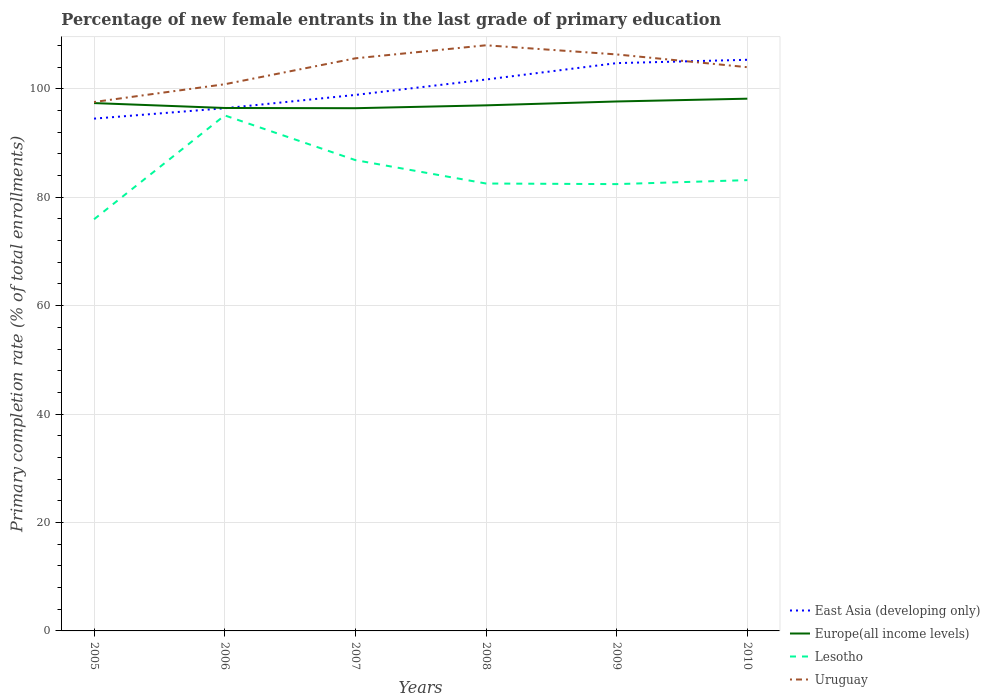How many different coloured lines are there?
Offer a terse response. 4. Does the line corresponding to Uruguay intersect with the line corresponding to East Asia (developing only)?
Make the answer very short. Yes. Across all years, what is the maximum percentage of new female entrants in Uruguay?
Offer a terse response. 97.57. What is the total percentage of new female entrants in Europe(all income levels) in the graph?
Your answer should be very brief. 0.42. What is the difference between the highest and the second highest percentage of new female entrants in Lesotho?
Provide a succinct answer. 19.16. What is the difference between the highest and the lowest percentage of new female entrants in East Asia (developing only)?
Offer a very short reply. 3. Is the percentage of new female entrants in East Asia (developing only) strictly greater than the percentage of new female entrants in Lesotho over the years?
Give a very brief answer. No. How many lines are there?
Offer a terse response. 4. Does the graph contain grids?
Keep it short and to the point. Yes. Where does the legend appear in the graph?
Provide a short and direct response. Bottom right. How many legend labels are there?
Offer a terse response. 4. What is the title of the graph?
Give a very brief answer. Percentage of new female entrants in the last grade of primary education. What is the label or title of the Y-axis?
Your answer should be very brief. Primary completion rate (% of total enrollments). What is the Primary completion rate (% of total enrollments) of East Asia (developing only) in 2005?
Your answer should be compact. 94.5. What is the Primary completion rate (% of total enrollments) in Europe(all income levels) in 2005?
Your response must be concise. 97.37. What is the Primary completion rate (% of total enrollments) of Lesotho in 2005?
Your answer should be very brief. 75.94. What is the Primary completion rate (% of total enrollments) of Uruguay in 2005?
Ensure brevity in your answer.  97.57. What is the Primary completion rate (% of total enrollments) of East Asia (developing only) in 2006?
Your answer should be compact. 96.42. What is the Primary completion rate (% of total enrollments) of Europe(all income levels) in 2006?
Keep it short and to the point. 96.47. What is the Primary completion rate (% of total enrollments) in Lesotho in 2006?
Keep it short and to the point. 95.1. What is the Primary completion rate (% of total enrollments) in Uruguay in 2006?
Make the answer very short. 100.85. What is the Primary completion rate (% of total enrollments) in East Asia (developing only) in 2007?
Provide a succinct answer. 98.88. What is the Primary completion rate (% of total enrollments) in Europe(all income levels) in 2007?
Provide a succinct answer. 96.43. What is the Primary completion rate (% of total enrollments) in Lesotho in 2007?
Ensure brevity in your answer.  86.85. What is the Primary completion rate (% of total enrollments) of Uruguay in 2007?
Your response must be concise. 105.63. What is the Primary completion rate (% of total enrollments) of East Asia (developing only) in 2008?
Your answer should be very brief. 101.72. What is the Primary completion rate (% of total enrollments) in Europe(all income levels) in 2008?
Offer a very short reply. 96.96. What is the Primary completion rate (% of total enrollments) of Lesotho in 2008?
Your answer should be compact. 82.54. What is the Primary completion rate (% of total enrollments) of Uruguay in 2008?
Provide a short and direct response. 108.04. What is the Primary completion rate (% of total enrollments) in East Asia (developing only) in 2009?
Give a very brief answer. 104.75. What is the Primary completion rate (% of total enrollments) in Europe(all income levels) in 2009?
Give a very brief answer. 97.67. What is the Primary completion rate (% of total enrollments) in Lesotho in 2009?
Ensure brevity in your answer.  82.43. What is the Primary completion rate (% of total enrollments) of Uruguay in 2009?
Give a very brief answer. 106.35. What is the Primary completion rate (% of total enrollments) in East Asia (developing only) in 2010?
Give a very brief answer. 105.36. What is the Primary completion rate (% of total enrollments) of Europe(all income levels) in 2010?
Your answer should be compact. 98.18. What is the Primary completion rate (% of total enrollments) of Lesotho in 2010?
Give a very brief answer. 83.16. What is the Primary completion rate (% of total enrollments) in Uruguay in 2010?
Provide a succinct answer. 103.99. Across all years, what is the maximum Primary completion rate (% of total enrollments) in East Asia (developing only)?
Provide a short and direct response. 105.36. Across all years, what is the maximum Primary completion rate (% of total enrollments) in Europe(all income levels)?
Provide a succinct answer. 98.18. Across all years, what is the maximum Primary completion rate (% of total enrollments) in Lesotho?
Your answer should be compact. 95.1. Across all years, what is the maximum Primary completion rate (% of total enrollments) in Uruguay?
Ensure brevity in your answer.  108.04. Across all years, what is the minimum Primary completion rate (% of total enrollments) of East Asia (developing only)?
Your answer should be very brief. 94.5. Across all years, what is the minimum Primary completion rate (% of total enrollments) of Europe(all income levels)?
Keep it short and to the point. 96.43. Across all years, what is the minimum Primary completion rate (% of total enrollments) in Lesotho?
Keep it short and to the point. 75.94. Across all years, what is the minimum Primary completion rate (% of total enrollments) in Uruguay?
Ensure brevity in your answer.  97.57. What is the total Primary completion rate (% of total enrollments) of East Asia (developing only) in the graph?
Your response must be concise. 601.63. What is the total Primary completion rate (% of total enrollments) in Europe(all income levels) in the graph?
Offer a terse response. 583.08. What is the total Primary completion rate (% of total enrollments) in Lesotho in the graph?
Make the answer very short. 506.02. What is the total Primary completion rate (% of total enrollments) in Uruguay in the graph?
Provide a succinct answer. 622.43. What is the difference between the Primary completion rate (% of total enrollments) in East Asia (developing only) in 2005 and that in 2006?
Your answer should be compact. -1.92. What is the difference between the Primary completion rate (% of total enrollments) in Europe(all income levels) in 2005 and that in 2006?
Ensure brevity in your answer.  0.9. What is the difference between the Primary completion rate (% of total enrollments) of Lesotho in 2005 and that in 2006?
Your response must be concise. -19.16. What is the difference between the Primary completion rate (% of total enrollments) of Uruguay in 2005 and that in 2006?
Keep it short and to the point. -3.28. What is the difference between the Primary completion rate (% of total enrollments) in East Asia (developing only) in 2005 and that in 2007?
Offer a very short reply. -4.37. What is the difference between the Primary completion rate (% of total enrollments) of Europe(all income levels) in 2005 and that in 2007?
Provide a succinct answer. 0.94. What is the difference between the Primary completion rate (% of total enrollments) of Lesotho in 2005 and that in 2007?
Give a very brief answer. -10.91. What is the difference between the Primary completion rate (% of total enrollments) of Uruguay in 2005 and that in 2007?
Make the answer very short. -8.06. What is the difference between the Primary completion rate (% of total enrollments) of East Asia (developing only) in 2005 and that in 2008?
Give a very brief answer. -7.22. What is the difference between the Primary completion rate (% of total enrollments) in Europe(all income levels) in 2005 and that in 2008?
Give a very brief answer. 0.42. What is the difference between the Primary completion rate (% of total enrollments) in Lesotho in 2005 and that in 2008?
Offer a very short reply. -6.6. What is the difference between the Primary completion rate (% of total enrollments) of Uruguay in 2005 and that in 2008?
Your answer should be very brief. -10.47. What is the difference between the Primary completion rate (% of total enrollments) of East Asia (developing only) in 2005 and that in 2009?
Your response must be concise. -10.24. What is the difference between the Primary completion rate (% of total enrollments) in Europe(all income levels) in 2005 and that in 2009?
Ensure brevity in your answer.  -0.3. What is the difference between the Primary completion rate (% of total enrollments) of Lesotho in 2005 and that in 2009?
Offer a very short reply. -6.48. What is the difference between the Primary completion rate (% of total enrollments) in Uruguay in 2005 and that in 2009?
Your answer should be compact. -8.78. What is the difference between the Primary completion rate (% of total enrollments) in East Asia (developing only) in 2005 and that in 2010?
Your answer should be very brief. -10.86. What is the difference between the Primary completion rate (% of total enrollments) in Europe(all income levels) in 2005 and that in 2010?
Make the answer very short. -0.81. What is the difference between the Primary completion rate (% of total enrollments) of Lesotho in 2005 and that in 2010?
Offer a very short reply. -7.22. What is the difference between the Primary completion rate (% of total enrollments) of Uruguay in 2005 and that in 2010?
Give a very brief answer. -6.42. What is the difference between the Primary completion rate (% of total enrollments) of East Asia (developing only) in 2006 and that in 2007?
Provide a succinct answer. -2.46. What is the difference between the Primary completion rate (% of total enrollments) in Europe(all income levels) in 2006 and that in 2007?
Offer a terse response. 0.04. What is the difference between the Primary completion rate (% of total enrollments) of Lesotho in 2006 and that in 2007?
Your answer should be compact. 8.25. What is the difference between the Primary completion rate (% of total enrollments) of Uruguay in 2006 and that in 2007?
Provide a short and direct response. -4.78. What is the difference between the Primary completion rate (% of total enrollments) of East Asia (developing only) in 2006 and that in 2008?
Provide a short and direct response. -5.3. What is the difference between the Primary completion rate (% of total enrollments) of Europe(all income levels) in 2006 and that in 2008?
Provide a short and direct response. -0.49. What is the difference between the Primary completion rate (% of total enrollments) of Lesotho in 2006 and that in 2008?
Offer a very short reply. 12.56. What is the difference between the Primary completion rate (% of total enrollments) of Uruguay in 2006 and that in 2008?
Offer a very short reply. -7.19. What is the difference between the Primary completion rate (% of total enrollments) of East Asia (developing only) in 2006 and that in 2009?
Your answer should be compact. -8.33. What is the difference between the Primary completion rate (% of total enrollments) of Europe(all income levels) in 2006 and that in 2009?
Offer a terse response. -1.2. What is the difference between the Primary completion rate (% of total enrollments) of Lesotho in 2006 and that in 2009?
Provide a succinct answer. 12.68. What is the difference between the Primary completion rate (% of total enrollments) in Uruguay in 2006 and that in 2009?
Offer a very short reply. -5.5. What is the difference between the Primary completion rate (% of total enrollments) of East Asia (developing only) in 2006 and that in 2010?
Provide a short and direct response. -8.94. What is the difference between the Primary completion rate (% of total enrollments) in Europe(all income levels) in 2006 and that in 2010?
Provide a succinct answer. -1.71. What is the difference between the Primary completion rate (% of total enrollments) in Lesotho in 2006 and that in 2010?
Your response must be concise. 11.94. What is the difference between the Primary completion rate (% of total enrollments) in Uruguay in 2006 and that in 2010?
Give a very brief answer. -3.15. What is the difference between the Primary completion rate (% of total enrollments) of East Asia (developing only) in 2007 and that in 2008?
Offer a very short reply. -2.85. What is the difference between the Primary completion rate (% of total enrollments) of Europe(all income levels) in 2007 and that in 2008?
Offer a very short reply. -0.53. What is the difference between the Primary completion rate (% of total enrollments) of Lesotho in 2007 and that in 2008?
Ensure brevity in your answer.  4.32. What is the difference between the Primary completion rate (% of total enrollments) of Uruguay in 2007 and that in 2008?
Ensure brevity in your answer.  -2.41. What is the difference between the Primary completion rate (% of total enrollments) of East Asia (developing only) in 2007 and that in 2009?
Provide a short and direct response. -5.87. What is the difference between the Primary completion rate (% of total enrollments) of Europe(all income levels) in 2007 and that in 2009?
Offer a terse response. -1.24. What is the difference between the Primary completion rate (% of total enrollments) of Lesotho in 2007 and that in 2009?
Give a very brief answer. 4.43. What is the difference between the Primary completion rate (% of total enrollments) of Uruguay in 2007 and that in 2009?
Keep it short and to the point. -0.72. What is the difference between the Primary completion rate (% of total enrollments) in East Asia (developing only) in 2007 and that in 2010?
Make the answer very short. -6.48. What is the difference between the Primary completion rate (% of total enrollments) in Europe(all income levels) in 2007 and that in 2010?
Provide a short and direct response. -1.75. What is the difference between the Primary completion rate (% of total enrollments) in Lesotho in 2007 and that in 2010?
Ensure brevity in your answer.  3.69. What is the difference between the Primary completion rate (% of total enrollments) of Uruguay in 2007 and that in 2010?
Your response must be concise. 1.64. What is the difference between the Primary completion rate (% of total enrollments) in East Asia (developing only) in 2008 and that in 2009?
Provide a succinct answer. -3.02. What is the difference between the Primary completion rate (% of total enrollments) in Europe(all income levels) in 2008 and that in 2009?
Provide a short and direct response. -0.72. What is the difference between the Primary completion rate (% of total enrollments) of Lesotho in 2008 and that in 2009?
Ensure brevity in your answer.  0.11. What is the difference between the Primary completion rate (% of total enrollments) in Uruguay in 2008 and that in 2009?
Ensure brevity in your answer.  1.69. What is the difference between the Primary completion rate (% of total enrollments) in East Asia (developing only) in 2008 and that in 2010?
Your answer should be very brief. -3.64. What is the difference between the Primary completion rate (% of total enrollments) in Europe(all income levels) in 2008 and that in 2010?
Keep it short and to the point. -1.23. What is the difference between the Primary completion rate (% of total enrollments) of Lesotho in 2008 and that in 2010?
Offer a very short reply. -0.62. What is the difference between the Primary completion rate (% of total enrollments) in Uruguay in 2008 and that in 2010?
Provide a short and direct response. 4.04. What is the difference between the Primary completion rate (% of total enrollments) in East Asia (developing only) in 2009 and that in 2010?
Keep it short and to the point. -0.61. What is the difference between the Primary completion rate (% of total enrollments) of Europe(all income levels) in 2009 and that in 2010?
Keep it short and to the point. -0.51. What is the difference between the Primary completion rate (% of total enrollments) in Lesotho in 2009 and that in 2010?
Give a very brief answer. -0.73. What is the difference between the Primary completion rate (% of total enrollments) in Uruguay in 2009 and that in 2010?
Keep it short and to the point. 2.35. What is the difference between the Primary completion rate (% of total enrollments) of East Asia (developing only) in 2005 and the Primary completion rate (% of total enrollments) of Europe(all income levels) in 2006?
Provide a short and direct response. -1.97. What is the difference between the Primary completion rate (% of total enrollments) of East Asia (developing only) in 2005 and the Primary completion rate (% of total enrollments) of Lesotho in 2006?
Provide a succinct answer. -0.6. What is the difference between the Primary completion rate (% of total enrollments) of East Asia (developing only) in 2005 and the Primary completion rate (% of total enrollments) of Uruguay in 2006?
Offer a terse response. -6.34. What is the difference between the Primary completion rate (% of total enrollments) of Europe(all income levels) in 2005 and the Primary completion rate (% of total enrollments) of Lesotho in 2006?
Your answer should be very brief. 2.27. What is the difference between the Primary completion rate (% of total enrollments) of Europe(all income levels) in 2005 and the Primary completion rate (% of total enrollments) of Uruguay in 2006?
Keep it short and to the point. -3.48. What is the difference between the Primary completion rate (% of total enrollments) of Lesotho in 2005 and the Primary completion rate (% of total enrollments) of Uruguay in 2006?
Offer a terse response. -24.91. What is the difference between the Primary completion rate (% of total enrollments) in East Asia (developing only) in 2005 and the Primary completion rate (% of total enrollments) in Europe(all income levels) in 2007?
Keep it short and to the point. -1.93. What is the difference between the Primary completion rate (% of total enrollments) in East Asia (developing only) in 2005 and the Primary completion rate (% of total enrollments) in Lesotho in 2007?
Ensure brevity in your answer.  7.65. What is the difference between the Primary completion rate (% of total enrollments) in East Asia (developing only) in 2005 and the Primary completion rate (% of total enrollments) in Uruguay in 2007?
Keep it short and to the point. -11.13. What is the difference between the Primary completion rate (% of total enrollments) in Europe(all income levels) in 2005 and the Primary completion rate (% of total enrollments) in Lesotho in 2007?
Your answer should be very brief. 10.52. What is the difference between the Primary completion rate (% of total enrollments) in Europe(all income levels) in 2005 and the Primary completion rate (% of total enrollments) in Uruguay in 2007?
Your answer should be very brief. -8.26. What is the difference between the Primary completion rate (% of total enrollments) in Lesotho in 2005 and the Primary completion rate (% of total enrollments) in Uruguay in 2007?
Offer a very short reply. -29.69. What is the difference between the Primary completion rate (% of total enrollments) of East Asia (developing only) in 2005 and the Primary completion rate (% of total enrollments) of Europe(all income levels) in 2008?
Your answer should be very brief. -2.45. What is the difference between the Primary completion rate (% of total enrollments) in East Asia (developing only) in 2005 and the Primary completion rate (% of total enrollments) in Lesotho in 2008?
Ensure brevity in your answer.  11.97. What is the difference between the Primary completion rate (% of total enrollments) in East Asia (developing only) in 2005 and the Primary completion rate (% of total enrollments) in Uruguay in 2008?
Your answer should be very brief. -13.53. What is the difference between the Primary completion rate (% of total enrollments) of Europe(all income levels) in 2005 and the Primary completion rate (% of total enrollments) of Lesotho in 2008?
Keep it short and to the point. 14.84. What is the difference between the Primary completion rate (% of total enrollments) in Europe(all income levels) in 2005 and the Primary completion rate (% of total enrollments) in Uruguay in 2008?
Offer a terse response. -10.66. What is the difference between the Primary completion rate (% of total enrollments) in Lesotho in 2005 and the Primary completion rate (% of total enrollments) in Uruguay in 2008?
Your answer should be compact. -32.1. What is the difference between the Primary completion rate (% of total enrollments) in East Asia (developing only) in 2005 and the Primary completion rate (% of total enrollments) in Europe(all income levels) in 2009?
Your response must be concise. -3.17. What is the difference between the Primary completion rate (% of total enrollments) in East Asia (developing only) in 2005 and the Primary completion rate (% of total enrollments) in Lesotho in 2009?
Your answer should be very brief. 12.08. What is the difference between the Primary completion rate (% of total enrollments) in East Asia (developing only) in 2005 and the Primary completion rate (% of total enrollments) in Uruguay in 2009?
Give a very brief answer. -11.84. What is the difference between the Primary completion rate (% of total enrollments) of Europe(all income levels) in 2005 and the Primary completion rate (% of total enrollments) of Lesotho in 2009?
Offer a very short reply. 14.95. What is the difference between the Primary completion rate (% of total enrollments) of Europe(all income levels) in 2005 and the Primary completion rate (% of total enrollments) of Uruguay in 2009?
Provide a short and direct response. -8.97. What is the difference between the Primary completion rate (% of total enrollments) in Lesotho in 2005 and the Primary completion rate (% of total enrollments) in Uruguay in 2009?
Keep it short and to the point. -30.41. What is the difference between the Primary completion rate (% of total enrollments) in East Asia (developing only) in 2005 and the Primary completion rate (% of total enrollments) in Europe(all income levels) in 2010?
Give a very brief answer. -3.68. What is the difference between the Primary completion rate (% of total enrollments) in East Asia (developing only) in 2005 and the Primary completion rate (% of total enrollments) in Lesotho in 2010?
Give a very brief answer. 11.34. What is the difference between the Primary completion rate (% of total enrollments) in East Asia (developing only) in 2005 and the Primary completion rate (% of total enrollments) in Uruguay in 2010?
Make the answer very short. -9.49. What is the difference between the Primary completion rate (% of total enrollments) of Europe(all income levels) in 2005 and the Primary completion rate (% of total enrollments) of Lesotho in 2010?
Give a very brief answer. 14.21. What is the difference between the Primary completion rate (% of total enrollments) in Europe(all income levels) in 2005 and the Primary completion rate (% of total enrollments) in Uruguay in 2010?
Offer a very short reply. -6.62. What is the difference between the Primary completion rate (% of total enrollments) of Lesotho in 2005 and the Primary completion rate (% of total enrollments) of Uruguay in 2010?
Ensure brevity in your answer.  -28.05. What is the difference between the Primary completion rate (% of total enrollments) in East Asia (developing only) in 2006 and the Primary completion rate (% of total enrollments) in Europe(all income levels) in 2007?
Provide a short and direct response. -0.01. What is the difference between the Primary completion rate (% of total enrollments) in East Asia (developing only) in 2006 and the Primary completion rate (% of total enrollments) in Lesotho in 2007?
Your answer should be compact. 9.57. What is the difference between the Primary completion rate (% of total enrollments) in East Asia (developing only) in 2006 and the Primary completion rate (% of total enrollments) in Uruguay in 2007?
Offer a very short reply. -9.21. What is the difference between the Primary completion rate (% of total enrollments) in Europe(all income levels) in 2006 and the Primary completion rate (% of total enrollments) in Lesotho in 2007?
Your answer should be compact. 9.62. What is the difference between the Primary completion rate (% of total enrollments) in Europe(all income levels) in 2006 and the Primary completion rate (% of total enrollments) in Uruguay in 2007?
Your answer should be very brief. -9.16. What is the difference between the Primary completion rate (% of total enrollments) in Lesotho in 2006 and the Primary completion rate (% of total enrollments) in Uruguay in 2007?
Make the answer very short. -10.53. What is the difference between the Primary completion rate (% of total enrollments) in East Asia (developing only) in 2006 and the Primary completion rate (% of total enrollments) in Europe(all income levels) in 2008?
Make the answer very short. -0.54. What is the difference between the Primary completion rate (% of total enrollments) in East Asia (developing only) in 2006 and the Primary completion rate (% of total enrollments) in Lesotho in 2008?
Provide a short and direct response. 13.88. What is the difference between the Primary completion rate (% of total enrollments) of East Asia (developing only) in 2006 and the Primary completion rate (% of total enrollments) of Uruguay in 2008?
Make the answer very short. -11.62. What is the difference between the Primary completion rate (% of total enrollments) of Europe(all income levels) in 2006 and the Primary completion rate (% of total enrollments) of Lesotho in 2008?
Your response must be concise. 13.93. What is the difference between the Primary completion rate (% of total enrollments) in Europe(all income levels) in 2006 and the Primary completion rate (% of total enrollments) in Uruguay in 2008?
Ensure brevity in your answer.  -11.57. What is the difference between the Primary completion rate (% of total enrollments) of Lesotho in 2006 and the Primary completion rate (% of total enrollments) of Uruguay in 2008?
Make the answer very short. -12.94. What is the difference between the Primary completion rate (% of total enrollments) in East Asia (developing only) in 2006 and the Primary completion rate (% of total enrollments) in Europe(all income levels) in 2009?
Offer a very short reply. -1.25. What is the difference between the Primary completion rate (% of total enrollments) in East Asia (developing only) in 2006 and the Primary completion rate (% of total enrollments) in Lesotho in 2009?
Offer a very short reply. 14. What is the difference between the Primary completion rate (% of total enrollments) of East Asia (developing only) in 2006 and the Primary completion rate (% of total enrollments) of Uruguay in 2009?
Your response must be concise. -9.93. What is the difference between the Primary completion rate (% of total enrollments) in Europe(all income levels) in 2006 and the Primary completion rate (% of total enrollments) in Lesotho in 2009?
Give a very brief answer. 14.04. What is the difference between the Primary completion rate (% of total enrollments) of Europe(all income levels) in 2006 and the Primary completion rate (% of total enrollments) of Uruguay in 2009?
Your answer should be very brief. -9.88. What is the difference between the Primary completion rate (% of total enrollments) in Lesotho in 2006 and the Primary completion rate (% of total enrollments) in Uruguay in 2009?
Provide a short and direct response. -11.25. What is the difference between the Primary completion rate (% of total enrollments) of East Asia (developing only) in 2006 and the Primary completion rate (% of total enrollments) of Europe(all income levels) in 2010?
Your answer should be very brief. -1.76. What is the difference between the Primary completion rate (% of total enrollments) in East Asia (developing only) in 2006 and the Primary completion rate (% of total enrollments) in Lesotho in 2010?
Keep it short and to the point. 13.26. What is the difference between the Primary completion rate (% of total enrollments) in East Asia (developing only) in 2006 and the Primary completion rate (% of total enrollments) in Uruguay in 2010?
Make the answer very short. -7.57. What is the difference between the Primary completion rate (% of total enrollments) of Europe(all income levels) in 2006 and the Primary completion rate (% of total enrollments) of Lesotho in 2010?
Your answer should be compact. 13.31. What is the difference between the Primary completion rate (% of total enrollments) in Europe(all income levels) in 2006 and the Primary completion rate (% of total enrollments) in Uruguay in 2010?
Offer a terse response. -7.52. What is the difference between the Primary completion rate (% of total enrollments) of Lesotho in 2006 and the Primary completion rate (% of total enrollments) of Uruguay in 2010?
Provide a short and direct response. -8.89. What is the difference between the Primary completion rate (% of total enrollments) in East Asia (developing only) in 2007 and the Primary completion rate (% of total enrollments) in Europe(all income levels) in 2008?
Your answer should be very brief. 1.92. What is the difference between the Primary completion rate (% of total enrollments) of East Asia (developing only) in 2007 and the Primary completion rate (% of total enrollments) of Lesotho in 2008?
Your response must be concise. 16.34. What is the difference between the Primary completion rate (% of total enrollments) in East Asia (developing only) in 2007 and the Primary completion rate (% of total enrollments) in Uruguay in 2008?
Give a very brief answer. -9.16. What is the difference between the Primary completion rate (% of total enrollments) of Europe(all income levels) in 2007 and the Primary completion rate (% of total enrollments) of Lesotho in 2008?
Make the answer very short. 13.89. What is the difference between the Primary completion rate (% of total enrollments) of Europe(all income levels) in 2007 and the Primary completion rate (% of total enrollments) of Uruguay in 2008?
Your response must be concise. -11.61. What is the difference between the Primary completion rate (% of total enrollments) of Lesotho in 2007 and the Primary completion rate (% of total enrollments) of Uruguay in 2008?
Make the answer very short. -21.18. What is the difference between the Primary completion rate (% of total enrollments) in East Asia (developing only) in 2007 and the Primary completion rate (% of total enrollments) in Europe(all income levels) in 2009?
Keep it short and to the point. 1.21. What is the difference between the Primary completion rate (% of total enrollments) in East Asia (developing only) in 2007 and the Primary completion rate (% of total enrollments) in Lesotho in 2009?
Offer a very short reply. 16.45. What is the difference between the Primary completion rate (% of total enrollments) in East Asia (developing only) in 2007 and the Primary completion rate (% of total enrollments) in Uruguay in 2009?
Make the answer very short. -7.47. What is the difference between the Primary completion rate (% of total enrollments) of Europe(all income levels) in 2007 and the Primary completion rate (% of total enrollments) of Lesotho in 2009?
Give a very brief answer. 14. What is the difference between the Primary completion rate (% of total enrollments) of Europe(all income levels) in 2007 and the Primary completion rate (% of total enrollments) of Uruguay in 2009?
Offer a very short reply. -9.92. What is the difference between the Primary completion rate (% of total enrollments) of Lesotho in 2007 and the Primary completion rate (% of total enrollments) of Uruguay in 2009?
Provide a short and direct response. -19.49. What is the difference between the Primary completion rate (% of total enrollments) in East Asia (developing only) in 2007 and the Primary completion rate (% of total enrollments) in Europe(all income levels) in 2010?
Give a very brief answer. 0.69. What is the difference between the Primary completion rate (% of total enrollments) in East Asia (developing only) in 2007 and the Primary completion rate (% of total enrollments) in Lesotho in 2010?
Make the answer very short. 15.72. What is the difference between the Primary completion rate (% of total enrollments) of East Asia (developing only) in 2007 and the Primary completion rate (% of total enrollments) of Uruguay in 2010?
Offer a very short reply. -5.12. What is the difference between the Primary completion rate (% of total enrollments) of Europe(all income levels) in 2007 and the Primary completion rate (% of total enrollments) of Lesotho in 2010?
Your response must be concise. 13.27. What is the difference between the Primary completion rate (% of total enrollments) in Europe(all income levels) in 2007 and the Primary completion rate (% of total enrollments) in Uruguay in 2010?
Provide a short and direct response. -7.56. What is the difference between the Primary completion rate (% of total enrollments) in Lesotho in 2007 and the Primary completion rate (% of total enrollments) in Uruguay in 2010?
Your answer should be very brief. -17.14. What is the difference between the Primary completion rate (% of total enrollments) of East Asia (developing only) in 2008 and the Primary completion rate (% of total enrollments) of Europe(all income levels) in 2009?
Ensure brevity in your answer.  4.05. What is the difference between the Primary completion rate (% of total enrollments) in East Asia (developing only) in 2008 and the Primary completion rate (% of total enrollments) in Lesotho in 2009?
Your answer should be very brief. 19.3. What is the difference between the Primary completion rate (% of total enrollments) in East Asia (developing only) in 2008 and the Primary completion rate (% of total enrollments) in Uruguay in 2009?
Ensure brevity in your answer.  -4.63. What is the difference between the Primary completion rate (% of total enrollments) in Europe(all income levels) in 2008 and the Primary completion rate (% of total enrollments) in Lesotho in 2009?
Provide a succinct answer. 14.53. What is the difference between the Primary completion rate (% of total enrollments) of Europe(all income levels) in 2008 and the Primary completion rate (% of total enrollments) of Uruguay in 2009?
Offer a terse response. -9.39. What is the difference between the Primary completion rate (% of total enrollments) in Lesotho in 2008 and the Primary completion rate (% of total enrollments) in Uruguay in 2009?
Offer a very short reply. -23.81. What is the difference between the Primary completion rate (% of total enrollments) of East Asia (developing only) in 2008 and the Primary completion rate (% of total enrollments) of Europe(all income levels) in 2010?
Provide a succinct answer. 3.54. What is the difference between the Primary completion rate (% of total enrollments) of East Asia (developing only) in 2008 and the Primary completion rate (% of total enrollments) of Lesotho in 2010?
Ensure brevity in your answer.  18.56. What is the difference between the Primary completion rate (% of total enrollments) of East Asia (developing only) in 2008 and the Primary completion rate (% of total enrollments) of Uruguay in 2010?
Make the answer very short. -2.27. What is the difference between the Primary completion rate (% of total enrollments) in Europe(all income levels) in 2008 and the Primary completion rate (% of total enrollments) in Lesotho in 2010?
Ensure brevity in your answer.  13.8. What is the difference between the Primary completion rate (% of total enrollments) in Europe(all income levels) in 2008 and the Primary completion rate (% of total enrollments) in Uruguay in 2010?
Your answer should be very brief. -7.04. What is the difference between the Primary completion rate (% of total enrollments) in Lesotho in 2008 and the Primary completion rate (% of total enrollments) in Uruguay in 2010?
Offer a very short reply. -21.46. What is the difference between the Primary completion rate (% of total enrollments) of East Asia (developing only) in 2009 and the Primary completion rate (% of total enrollments) of Europe(all income levels) in 2010?
Provide a succinct answer. 6.56. What is the difference between the Primary completion rate (% of total enrollments) in East Asia (developing only) in 2009 and the Primary completion rate (% of total enrollments) in Lesotho in 2010?
Make the answer very short. 21.59. What is the difference between the Primary completion rate (% of total enrollments) of East Asia (developing only) in 2009 and the Primary completion rate (% of total enrollments) of Uruguay in 2010?
Keep it short and to the point. 0.75. What is the difference between the Primary completion rate (% of total enrollments) in Europe(all income levels) in 2009 and the Primary completion rate (% of total enrollments) in Lesotho in 2010?
Offer a very short reply. 14.51. What is the difference between the Primary completion rate (% of total enrollments) in Europe(all income levels) in 2009 and the Primary completion rate (% of total enrollments) in Uruguay in 2010?
Offer a very short reply. -6.32. What is the difference between the Primary completion rate (% of total enrollments) of Lesotho in 2009 and the Primary completion rate (% of total enrollments) of Uruguay in 2010?
Keep it short and to the point. -21.57. What is the average Primary completion rate (% of total enrollments) in East Asia (developing only) per year?
Offer a very short reply. 100.27. What is the average Primary completion rate (% of total enrollments) of Europe(all income levels) per year?
Give a very brief answer. 97.18. What is the average Primary completion rate (% of total enrollments) in Lesotho per year?
Offer a very short reply. 84.34. What is the average Primary completion rate (% of total enrollments) in Uruguay per year?
Offer a terse response. 103.74. In the year 2005, what is the difference between the Primary completion rate (% of total enrollments) of East Asia (developing only) and Primary completion rate (% of total enrollments) of Europe(all income levels)?
Provide a short and direct response. -2.87. In the year 2005, what is the difference between the Primary completion rate (% of total enrollments) in East Asia (developing only) and Primary completion rate (% of total enrollments) in Lesotho?
Offer a very short reply. 18.56. In the year 2005, what is the difference between the Primary completion rate (% of total enrollments) of East Asia (developing only) and Primary completion rate (% of total enrollments) of Uruguay?
Provide a succinct answer. -3.07. In the year 2005, what is the difference between the Primary completion rate (% of total enrollments) of Europe(all income levels) and Primary completion rate (% of total enrollments) of Lesotho?
Provide a succinct answer. 21.43. In the year 2005, what is the difference between the Primary completion rate (% of total enrollments) of Europe(all income levels) and Primary completion rate (% of total enrollments) of Uruguay?
Ensure brevity in your answer.  -0.2. In the year 2005, what is the difference between the Primary completion rate (% of total enrollments) of Lesotho and Primary completion rate (% of total enrollments) of Uruguay?
Ensure brevity in your answer.  -21.63. In the year 2006, what is the difference between the Primary completion rate (% of total enrollments) of East Asia (developing only) and Primary completion rate (% of total enrollments) of Europe(all income levels)?
Your answer should be compact. -0.05. In the year 2006, what is the difference between the Primary completion rate (% of total enrollments) in East Asia (developing only) and Primary completion rate (% of total enrollments) in Lesotho?
Make the answer very short. 1.32. In the year 2006, what is the difference between the Primary completion rate (% of total enrollments) in East Asia (developing only) and Primary completion rate (% of total enrollments) in Uruguay?
Ensure brevity in your answer.  -4.43. In the year 2006, what is the difference between the Primary completion rate (% of total enrollments) in Europe(all income levels) and Primary completion rate (% of total enrollments) in Lesotho?
Give a very brief answer. 1.37. In the year 2006, what is the difference between the Primary completion rate (% of total enrollments) of Europe(all income levels) and Primary completion rate (% of total enrollments) of Uruguay?
Keep it short and to the point. -4.38. In the year 2006, what is the difference between the Primary completion rate (% of total enrollments) of Lesotho and Primary completion rate (% of total enrollments) of Uruguay?
Keep it short and to the point. -5.75. In the year 2007, what is the difference between the Primary completion rate (% of total enrollments) in East Asia (developing only) and Primary completion rate (% of total enrollments) in Europe(all income levels)?
Offer a terse response. 2.45. In the year 2007, what is the difference between the Primary completion rate (% of total enrollments) of East Asia (developing only) and Primary completion rate (% of total enrollments) of Lesotho?
Ensure brevity in your answer.  12.02. In the year 2007, what is the difference between the Primary completion rate (% of total enrollments) of East Asia (developing only) and Primary completion rate (% of total enrollments) of Uruguay?
Provide a short and direct response. -6.75. In the year 2007, what is the difference between the Primary completion rate (% of total enrollments) of Europe(all income levels) and Primary completion rate (% of total enrollments) of Lesotho?
Offer a terse response. 9.58. In the year 2007, what is the difference between the Primary completion rate (% of total enrollments) in Europe(all income levels) and Primary completion rate (% of total enrollments) in Uruguay?
Your answer should be very brief. -9.2. In the year 2007, what is the difference between the Primary completion rate (% of total enrollments) of Lesotho and Primary completion rate (% of total enrollments) of Uruguay?
Make the answer very short. -18.78. In the year 2008, what is the difference between the Primary completion rate (% of total enrollments) in East Asia (developing only) and Primary completion rate (% of total enrollments) in Europe(all income levels)?
Give a very brief answer. 4.77. In the year 2008, what is the difference between the Primary completion rate (% of total enrollments) in East Asia (developing only) and Primary completion rate (% of total enrollments) in Lesotho?
Your response must be concise. 19.19. In the year 2008, what is the difference between the Primary completion rate (% of total enrollments) of East Asia (developing only) and Primary completion rate (% of total enrollments) of Uruguay?
Offer a terse response. -6.32. In the year 2008, what is the difference between the Primary completion rate (% of total enrollments) in Europe(all income levels) and Primary completion rate (% of total enrollments) in Lesotho?
Offer a terse response. 14.42. In the year 2008, what is the difference between the Primary completion rate (% of total enrollments) of Europe(all income levels) and Primary completion rate (% of total enrollments) of Uruguay?
Your response must be concise. -11.08. In the year 2008, what is the difference between the Primary completion rate (% of total enrollments) of Lesotho and Primary completion rate (% of total enrollments) of Uruguay?
Your answer should be very brief. -25.5. In the year 2009, what is the difference between the Primary completion rate (% of total enrollments) of East Asia (developing only) and Primary completion rate (% of total enrollments) of Europe(all income levels)?
Offer a terse response. 7.08. In the year 2009, what is the difference between the Primary completion rate (% of total enrollments) of East Asia (developing only) and Primary completion rate (% of total enrollments) of Lesotho?
Offer a terse response. 22.32. In the year 2009, what is the difference between the Primary completion rate (% of total enrollments) of East Asia (developing only) and Primary completion rate (% of total enrollments) of Uruguay?
Ensure brevity in your answer.  -1.6. In the year 2009, what is the difference between the Primary completion rate (% of total enrollments) in Europe(all income levels) and Primary completion rate (% of total enrollments) in Lesotho?
Offer a terse response. 15.25. In the year 2009, what is the difference between the Primary completion rate (% of total enrollments) in Europe(all income levels) and Primary completion rate (% of total enrollments) in Uruguay?
Your answer should be very brief. -8.68. In the year 2009, what is the difference between the Primary completion rate (% of total enrollments) in Lesotho and Primary completion rate (% of total enrollments) in Uruguay?
Offer a very short reply. -23.92. In the year 2010, what is the difference between the Primary completion rate (% of total enrollments) in East Asia (developing only) and Primary completion rate (% of total enrollments) in Europe(all income levels)?
Offer a very short reply. 7.18. In the year 2010, what is the difference between the Primary completion rate (% of total enrollments) of East Asia (developing only) and Primary completion rate (% of total enrollments) of Lesotho?
Your response must be concise. 22.2. In the year 2010, what is the difference between the Primary completion rate (% of total enrollments) in East Asia (developing only) and Primary completion rate (% of total enrollments) in Uruguay?
Your answer should be compact. 1.37. In the year 2010, what is the difference between the Primary completion rate (% of total enrollments) in Europe(all income levels) and Primary completion rate (% of total enrollments) in Lesotho?
Keep it short and to the point. 15.02. In the year 2010, what is the difference between the Primary completion rate (% of total enrollments) in Europe(all income levels) and Primary completion rate (% of total enrollments) in Uruguay?
Your response must be concise. -5.81. In the year 2010, what is the difference between the Primary completion rate (% of total enrollments) in Lesotho and Primary completion rate (% of total enrollments) in Uruguay?
Your response must be concise. -20.83. What is the ratio of the Primary completion rate (% of total enrollments) in East Asia (developing only) in 2005 to that in 2006?
Keep it short and to the point. 0.98. What is the ratio of the Primary completion rate (% of total enrollments) of Europe(all income levels) in 2005 to that in 2006?
Make the answer very short. 1.01. What is the ratio of the Primary completion rate (% of total enrollments) in Lesotho in 2005 to that in 2006?
Make the answer very short. 0.8. What is the ratio of the Primary completion rate (% of total enrollments) of Uruguay in 2005 to that in 2006?
Your response must be concise. 0.97. What is the ratio of the Primary completion rate (% of total enrollments) of East Asia (developing only) in 2005 to that in 2007?
Ensure brevity in your answer.  0.96. What is the ratio of the Primary completion rate (% of total enrollments) of Europe(all income levels) in 2005 to that in 2007?
Keep it short and to the point. 1.01. What is the ratio of the Primary completion rate (% of total enrollments) of Lesotho in 2005 to that in 2007?
Your answer should be very brief. 0.87. What is the ratio of the Primary completion rate (% of total enrollments) of Uruguay in 2005 to that in 2007?
Make the answer very short. 0.92. What is the ratio of the Primary completion rate (% of total enrollments) of East Asia (developing only) in 2005 to that in 2008?
Offer a terse response. 0.93. What is the ratio of the Primary completion rate (% of total enrollments) of Europe(all income levels) in 2005 to that in 2008?
Give a very brief answer. 1. What is the ratio of the Primary completion rate (% of total enrollments) in Lesotho in 2005 to that in 2008?
Make the answer very short. 0.92. What is the ratio of the Primary completion rate (% of total enrollments) in Uruguay in 2005 to that in 2008?
Your response must be concise. 0.9. What is the ratio of the Primary completion rate (% of total enrollments) of East Asia (developing only) in 2005 to that in 2009?
Ensure brevity in your answer.  0.9. What is the ratio of the Primary completion rate (% of total enrollments) in Europe(all income levels) in 2005 to that in 2009?
Your answer should be compact. 1. What is the ratio of the Primary completion rate (% of total enrollments) of Lesotho in 2005 to that in 2009?
Your answer should be very brief. 0.92. What is the ratio of the Primary completion rate (% of total enrollments) of Uruguay in 2005 to that in 2009?
Your answer should be compact. 0.92. What is the ratio of the Primary completion rate (% of total enrollments) in East Asia (developing only) in 2005 to that in 2010?
Your response must be concise. 0.9. What is the ratio of the Primary completion rate (% of total enrollments) of Europe(all income levels) in 2005 to that in 2010?
Provide a succinct answer. 0.99. What is the ratio of the Primary completion rate (% of total enrollments) in Lesotho in 2005 to that in 2010?
Your answer should be compact. 0.91. What is the ratio of the Primary completion rate (% of total enrollments) in Uruguay in 2005 to that in 2010?
Provide a succinct answer. 0.94. What is the ratio of the Primary completion rate (% of total enrollments) of East Asia (developing only) in 2006 to that in 2007?
Give a very brief answer. 0.98. What is the ratio of the Primary completion rate (% of total enrollments) in Europe(all income levels) in 2006 to that in 2007?
Your response must be concise. 1. What is the ratio of the Primary completion rate (% of total enrollments) of Lesotho in 2006 to that in 2007?
Offer a terse response. 1.09. What is the ratio of the Primary completion rate (% of total enrollments) of Uruguay in 2006 to that in 2007?
Provide a short and direct response. 0.95. What is the ratio of the Primary completion rate (% of total enrollments) in East Asia (developing only) in 2006 to that in 2008?
Offer a very short reply. 0.95. What is the ratio of the Primary completion rate (% of total enrollments) in Europe(all income levels) in 2006 to that in 2008?
Give a very brief answer. 0.99. What is the ratio of the Primary completion rate (% of total enrollments) in Lesotho in 2006 to that in 2008?
Give a very brief answer. 1.15. What is the ratio of the Primary completion rate (% of total enrollments) in Uruguay in 2006 to that in 2008?
Provide a short and direct response. 0.93. What is the ratio of the Primary completion rate (% of total enrollments) of East Asia (developing only) in 2006 to that in 2009?
Provide a succinct answer. 0.92. What is the ratio of the Primary completion rate (% of total enrollments) of Europe(all income levels) in 2006 to that in 2009?
Offer a very short reply. 0.99. What is the ratio of the Primary completion rate (% of total enrollments) of Lesotho in 2006 to that in 2009?
Keep it short and to the point. 1.15. What is the ratio of the Primary completion rate (% of total enrollments) in Uruguay in 2006 to that in 2009?
Offer a very short reply. 0.95. What is the ratio of the Primary completion rate (% of total enrollments) of East Asia (developing only) in 2006 to that in 2010?
Offer a very short reply. 0.92. What is the ratio of the Primary completion rate (% of total enrollments) in Europe(all income levels) in 2006 to that in 2010?
Offer a terse response. 0.98. What is the ratio of the Primary completion rate (% of total enrollments) of Lesotho in 2006 to that in 2010?
Provide a short and direct response. 1.14. What is the ratio of the Primary completion rate (% of total enrollments) in Uruguay in 2006 to that in 2010?
Make the answer very short. 0.97. What is the ratio of the Primary completion rate (% of total enrollments) of Lesotho in 2007 to that in 2008?
Ensure brevity in your answer.  1.05. What is the ratio of the Primary completion rate (% of total enrollments) of Uruguay in 2007 to that in 2008?
Keep it short and to the point. 0.98. What is the ratio of the Primary completion rate (% of total enrollments) in East Asia (developing only) in 2007 to that in 2009?
Offer a terse response. 0.94. What is the ratio of the Primary completion rate (% of total enrollments) in Europe(all income levels) in 2007 to that in 2009?
Provide a short and direct response. 0.99. What is the ratio of the Primary completion rate (% of total enrollments) of Lesotho in 2007 to that in 2009?
Provide a short and direct response. 1.05. What is the ratio of the Primary completion rate (% of total enrollments) of East Asia (developing only) in 2007 to that in 2010?
Make the answer very short. 0.94. What is the ratio of the Primary completion rate (% of total enrollments) of Europe(all income levels) in 2007 to that in 2010?
Provide a short and direct response. 0.98. What is the ratio of the Primary completion rate (% of total enrollments) of Lesotho in 2007 to that in 2010?
Provide a succinct answer. 1.04. What is the ratio of the Primary completion rate (% of total enrollments) of Uruguay in 2007 to that in 2010?
Your response must be concise. 1.02. What is the ratio of the Primary completion rate (% of total enrollments) in East Asia (developing only) in 2008 to that in 2009?
Give a very brief answer. 0.97. What is the ratio of the Primary completion rate (% of total enrollments) in Europe(all income levels) in 2008 to that in 2009?
Keep it short and to the point. 0.99. What is the ratio of the Primary completion rate (% of total enrollments) of Uruguay in 2008 to that in 2009?
Make the answer very short. 1.02. What is the ratio of the Primary completion rate (% of total enrollments) of East Asia (developing only) in 2008 to that in 2010?
Keep it short and to the point. 0.97. What is the ratio of the Primary completion rate (% of total enrollments) in Europe(all income levels) in 2008 to that in 2010?
Provide a succinct answer. 0.99. What is the ratio of the Primary completion rate (% of total enrollments) in Lesotho in 2008 to that in 2010?
Keep it short and to the point. 0.99. What is the ratio of the Primary completion rate (% of total enrollments) in Uruguay in 2008 to that in 2010?
Give a very brief answer. 1.04. What is the ratio of the Primary completion rate (% of total enrollments) of Uruguay in 2009 to that in 2010?
Your response must be concise. 1.02. What is the difference between the highest and the second highest Primary completion rate (% of total enrollments) of East Asia (developing only)?
Offer a terse response. 0.61. What is the difference between the highest and the second highest Primary completion rate (% of total enrollments) in Europe(all income levels)?
Offer a terse response. 0.51. What is the difference between the highest and the second highest Primary completion rate (% of total enrollments) of Lesotho?
Give a very brief answer. 8.25. What is the difference between the highest and the second highest Primary completion rate (% of total enrollments) of Uruguay?
Ensure brevity in your answer.  1.69. What is the difference between the highest and the lowest Primary completion rate (% of total enrollments) of East Asia (developing only)?
Your response must be concise. 10.86. What is the difference between the highest and the lowest Primary completion rate (% of total enrollments) of Europe(all income levels)?
Offer a terse response. 1.75. What is the difference between the highest and the lowest Primary completion rate (% of total enrollments) in Lesotho?
Give a very brief answer. 19.16. What is the difference between the highest and the lowest Primary completion rate (% of total enrollments) in Uruguay?
Your answer should be compact. 10.47. 